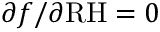Convert formula to latex. <formula><loc_0><loc_0><loc_500><loc_500>\partial f / \partial R H = 0</formula> 